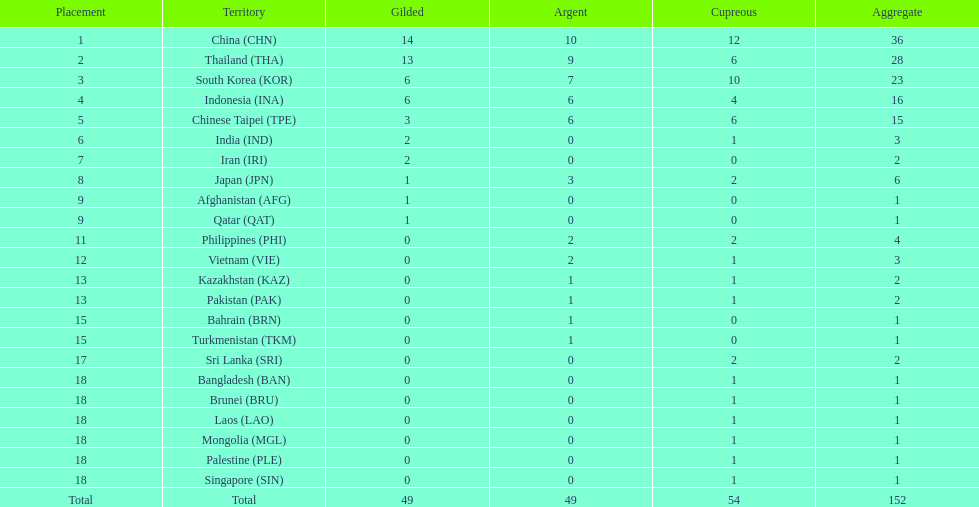Can you parse all the data within this table? {'header': ['Placement', 'Territory', 'Gilded', 'Argent', 'Cupreous', 'Aggregate'], 'rows': [['1', 'China\xa0(CHN)', '14', '10', '12', '36'], ['2', 'Thailand\xa0(THA)', '13', '9', '6', '28'], ['3', 'South Korea\xa0(KOR)', '6', '7', '10', '23'], ['4', 'Indonesia\xa0(INA)', '6', '6', '4', '16'], ['5', 'Chinese Taipei\xa0(TPE)', '3', '6', '6', '15'], ['6', 'India\xa0(IND)', '2', '0', '1', '3'], ['7', 'Iran\xa0(IRI)', '2', '0', '0', '2'], ['8', 'Japan\xa0(JPN)', '1', '3', '2', '6'], ['9', 'Afghanistan\xa0(AFG)', '1', '0', '0', '1'], ['9', 'Qatar\xa0(QAT)', '1', '0', '0', '1'], ['11', 'Philippines\xa0(PHI)', '0', '2', '2', '4'], ['12', 'Vietnam\xa0(VIE)', '0', '2', '1', '3'], ['13', 'Kazakhstan\xa0(KAZ)', '0', '1', '1', '2'], ['13', 'Pakistan\xa0(PAK)', '0', '1', '1', '2'], ['15', 'Bahrain\xa0(BRN)', '0', '1', '0', '1'], ['15', 'Turkmenistan\xa0(TKM)', '0', '1', '0', '1'], ['17', 'Sri Lanka\xa0(SRI)', '0', '0', '2', '2'], ['18', 'Bangladesh\xa0(BAN)', '0', '0', '1', '1'], ['18', 'Brunei\xa0(BRU)', '0', '0', '1', '1'], ['18', 'Laos\xa0(LAO)', '0', '0', '1', '1'], ['18', 'Mongolia\xa0(MGL)', '0', '0', '1', '1'], ['18', 'Palestine\xa0(PLE)', '0', '0', '1', '1'], ['18', 'Singapore\xa0(SIN)', '0', '0', '1', '1'], ['Total', 'Total', '49', '49', '54', '152']]} How many total gold medal have been given? 49. 